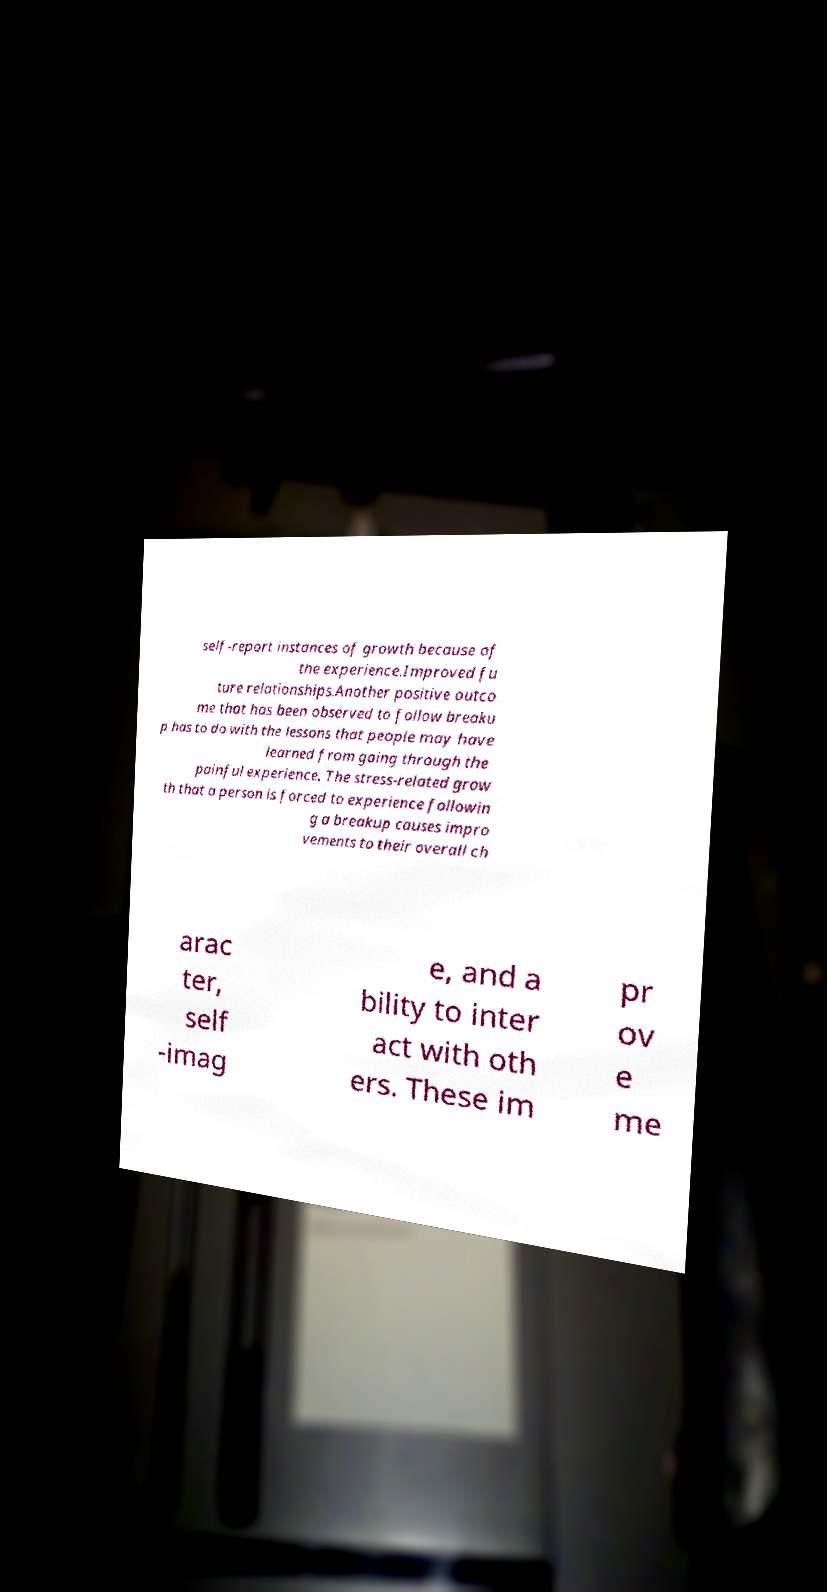Could you assist in decoding the text presented in this image and type it out clearly? self-report instances of growth because of the experience.Improved fu ture relationships.Another positive outco me that has been observed to follow breaku p has to do with the lessons that people may have learned from going through the painful experience. The stress-related grow th that a person is forced to experience followin g a breakup causes impro vements to their overall ch arac ter, self -imag e, and a bility to inter act with oth ers. These im pr ov e me 